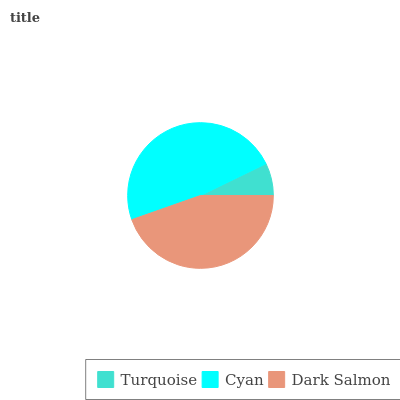Is Turquoise the minimum?
Answer yes or no. Yes. Is Cyan the maximum?
Answer yes or no. Yes. Is Dark Salmon the minimum?
Answer yes or no. No. Is Dark Salmon the maximum?
Answer yes or no. No. Is Cyan greater than Dark Salmon?
Answer yes or no. Yes. Is Dark Salmon less than Cyan?
Answer yes or no. Yes. Is Dark Salmon greater than Cyan?
Answer yes or no. No. Is Cyan less than Dark Salmon?
Answer yes or no. No. Is Dark Salmon the high median?
Answer yes or no. Yes. Is Dark Salmon the low median?
Answer yes or no. Yes. Is Cyan the high median?
Answer yes or no. No. Is Turquoise the low median?
Answer yes or no. No. 